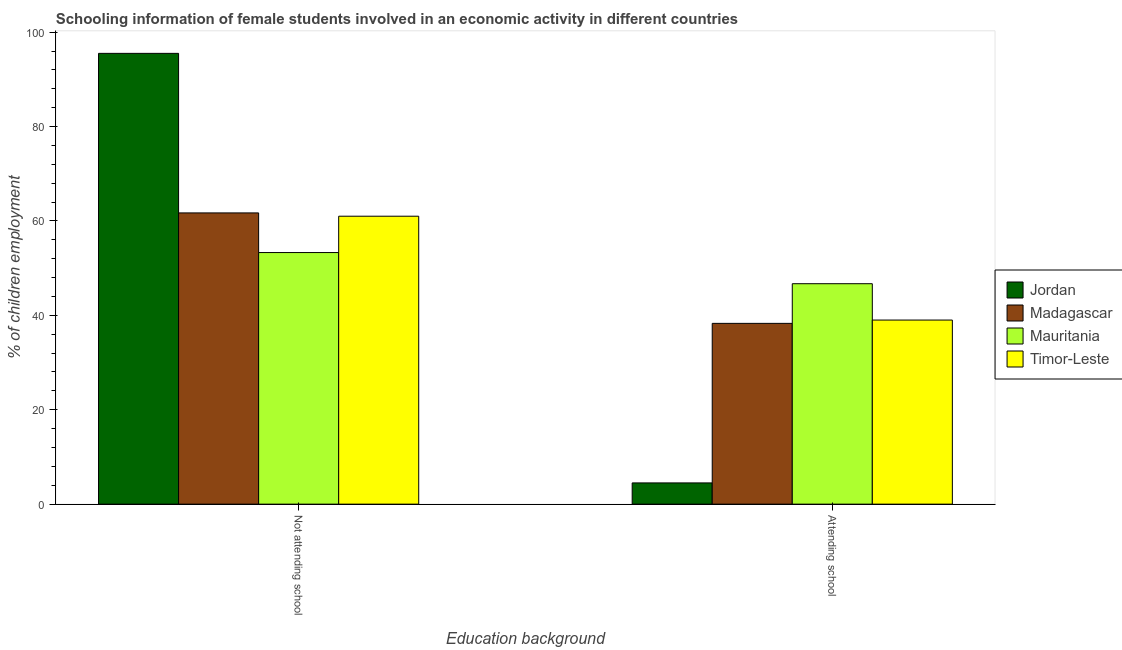How many groups of bars are there?
Provide a short and direct response. 2. How many bars are there on the 2nd tick from the right?
Give a very brief answer. 4. What is the label of the 2nd group of bars from the left?
Your answer should be very brief. Attending school. What is the percentage of employed females who are attending school in Timor-Leste?
Ensure brevity in your answer.  39. Across all countries, what is the maximum percentage of employed females who are not attending school?
Your answer should be very brief. 95.5. Across all countries, what is the minimum percentage of employed females who are not attending school?
Ensure brevity in your answer.  53.3. In which country was the percentage of employed females who are not attending school maximum?
Your answer should be very brief. Jordan. In which country was the percentage of employed females who are not attending school minimum?
Provide a short and direct response. Mauritania. What is the total percentage of employed females who are not attending school in the graph?
Your answer should be compact. 271.5. What is the difference between the percentage of employed females who are not attending school in Madagascar and that in Jordan?
Your answer should be very brief. -33.8. What is the difference between the percentage of employed females who are not attending school in Timor-Leste and the percentage of employed females who are attending school in Mauritania?
Your response must be concise. 14.3. What is the average percentage of employed females who are not attending school per country?
Offer a very short reply. 67.88. What is the difference between the percentage of employed females who are not attending school and percentage of employed females who are attending school in Timor-Leste?
Provide a short and direct response. 22. In how many countries, is the percentage of employed females who are not attending school greater than 20 %?
Make the answer very short. 4. What is the ratio of the percentage of employed females who are not attending school in Mauritania to that in Madagascar?
Provide a succinct answer. 0.86. Is the percentage of employed females who are not attending school in Mauritania less than that in Madagascar?
Your response must be concise. Yes. What does the 2nd bar from the left in Not attending school represents?
Offer a terse response. Madagascar. What does the 2nd bar from the right in Not attending school represents?
Offer a terse response. Mauritania. Are all the bars in the graph horizontal?
Offer a terse response. No. How many countries are there in the graph?
Provide a succinct answer. 4. What is the difference between two consecutive major ticks on the Y-axis?
Provide a succinct answer. 20. Are the values on the major ticks of Y-axis written in scientific E-notation?
Provide a short and direct response. No. Does the graph contain any zero values?
Provide a short and direct response. No. Does the graph contain grids?
Offer a terse response. No. Where does the legend appear in the graph?
Offer a very short reply. Center right. How are the legend labels stacked?
Your answer should be very brief. Vertical. What is the title of the graph?
Keep it short and to the point. Schooling information of female students involved in an economic activity in different countries. Does "Tajikistan" appear as one of the legend labels in the graph?
Keep it short and to the point. No. What is the label or title of the X-axis?
Your answer should be compact. Education background. What is the label or title of the Y-axis?
Your answer should be very brief. % of children employment. What is the % of children employment of Jordan in Not attending school?
Ensure brevity in your answer.  95.5. What is the % of children employment in Madagascar in Not attending school?
Offer a terse response. 61.7. What is the % of children employment of Mauritania in Not attending school?
Provide a succinct answer. 53.3. What is the % of children employment in Madagascar in Attending school?
Offer a terse response. 38.3. What is the % of children employment in Mauritania in Attending school?
Offer a terse response. 46.7. What is the % of children employment in Timor-Leste in Attending school?
Your response must be concise. 39. Across all Education background, what is the maximum % of children employment of Jordan?
Your response must be concise. 95.5. Across all Education background, what is the maximum % of children employment in Madagascar?
Offer a terse response. 61.7. Across all Education background, what is the maximum % of children employment of Mauritania?
Offer a terse response. 53.3. Across all Education background, what is the maximum % of children employment in Timor-Leste?
Keep it short and to the point. 61. Across all Education background, what is the minimum % of children employment in Jordan?
Ensure brevity in your answer.  4.5. Across all Education background, what is the minimum % of children employment in Madagascar?
Provide a succinct answer. 38.3. Across all Education background, what is the minimum % of children employment of Mauritania?
Give a very brief answer. 46.7. Across all Education background, what is the minimum % of children employment of Timor-Leste?
Give a very brief answer. 39. What is the difference between the % of children employment in Jordan in Not attending school and that in Attending school?
Your response must be concise. 91. What is the difference between the % of children employment in Madagascar in Not attending school and that in Attending school?
Offer a terse response. 23.4. What is the difference between the % of children employment in Mauritania in Not attending school and that in Attending school?
Your answer should be very brief. 6.6. What is the difference between the % of children employment of Timor-Leste in Not attending school and that in Attending school?
Provide a short and direct response. 22. What is the difference between the % of children employment of Jordan in Not attending school and the % of children employment of Madagascar in Attending school?
Your response must be concise. 57.2. What is the difference between the % of children employment in Jordan in Not attending school and the % of children employment in Mauritania in Attending school?
Your answer should be very brief. 48.8. What is the difference between the % of children employment in Jordan in Not attending school and the % of children employment in Timor-Leste in Attending school?
Make the answer very short. 56.5. What is the difference between the % of children employment of Madagascar in Not attending school and the % of children employment of Mauritania in Attending school?
Provide a short and direct response. 15. What is the difference between the % of children employment of Madagascar in Not attending school and the % of children employment of Timor-Leste in Attending school?
Offer a very short reply. 22.7. What is the average % of children employment of Mauritania per Education background?
Make the answer very short. 50. What is the difference between the % of children employment of Jordan and % of children employment of Madagascar in Not attending school?
Keep it short and to the point. 33.8. What is the difference between the % of children employment in Jordan and % of children employment in Mauritania in Not attending school?
Ensure brevity in your answer.  42.2. What is the difference between the % of children employment in Jordan and % of children employment in Timor-Leste in Not attending school?
Ensure brevity in your answer.  34.5. What is the difference between the % of children employment in Madagascar and % of children employment in Mauritania in Not attending school?
Your answer should be very brief. 8.4. What is the difference between the % of children employment in Madagascar and % of children employment in Timor-Leste in Not attending school?
Offer a very short reply. 0.7. What is the difference between the % of children employment of Jordan and % of children employment of Madagascar in Attending school?
Ensure brevity in your answer.  -33.8. What is the difference between the % of children employment of Jordan and % of children employment of Mauritania in Attending school?
Provide a short and direct response. -42.2. What is the difference between the % of children employment in Jordan and % of children employment in Timor-Leste in Attending school?
Give a very brief answer. -34.5. What is the difference between the % of children employment of Mauritania and % of children employment of Timor-Leste in Attending school?
Provide a short and direct response. 7.7. What is the ratio of the % of children employment in Jordan in Not attending school to that in Attending school?
Give a very brief answer. 21.22. What is the ratio of the % of children employment of Madagascar in Not attending school to that in Attending school?
Your answer should be compact. 1.61. What is the ratio of the % of children employment in Mauritania in Not attending school to that in Attending school?
Offer a terse response. 1.14. What is the ratio of the % of children employment of Timor-Leste in Not attending school to that in Attending school?
Offer a terse response. 1.56. What is the difference between the highest and the second highest % of children employment of Jordan?
Your answer should be very brief. 91. What is the difference between the highest and the second highest % of children employment in Madagascar?
Ensure brevity in your answer.  23.4. What is the difference between the highest and the second highest % of children employment of Mauritania?
Your response must be concise. 6.6. What is the difference between the highest and the second highest % of children employment in Timor-Leste?
Provide a succinct answer. 22. What is the difference between the highest and the lowest % of children employment in Jordan?
Offer a terse response. 91. What is the difference between the highest and the lowest % of children employment in Madagascar?
Give a very brief answer. 23.4. What is the difference between the highest and the lowest % of children employment in Timor-Leste?
Keep it short and to the point. 22. 